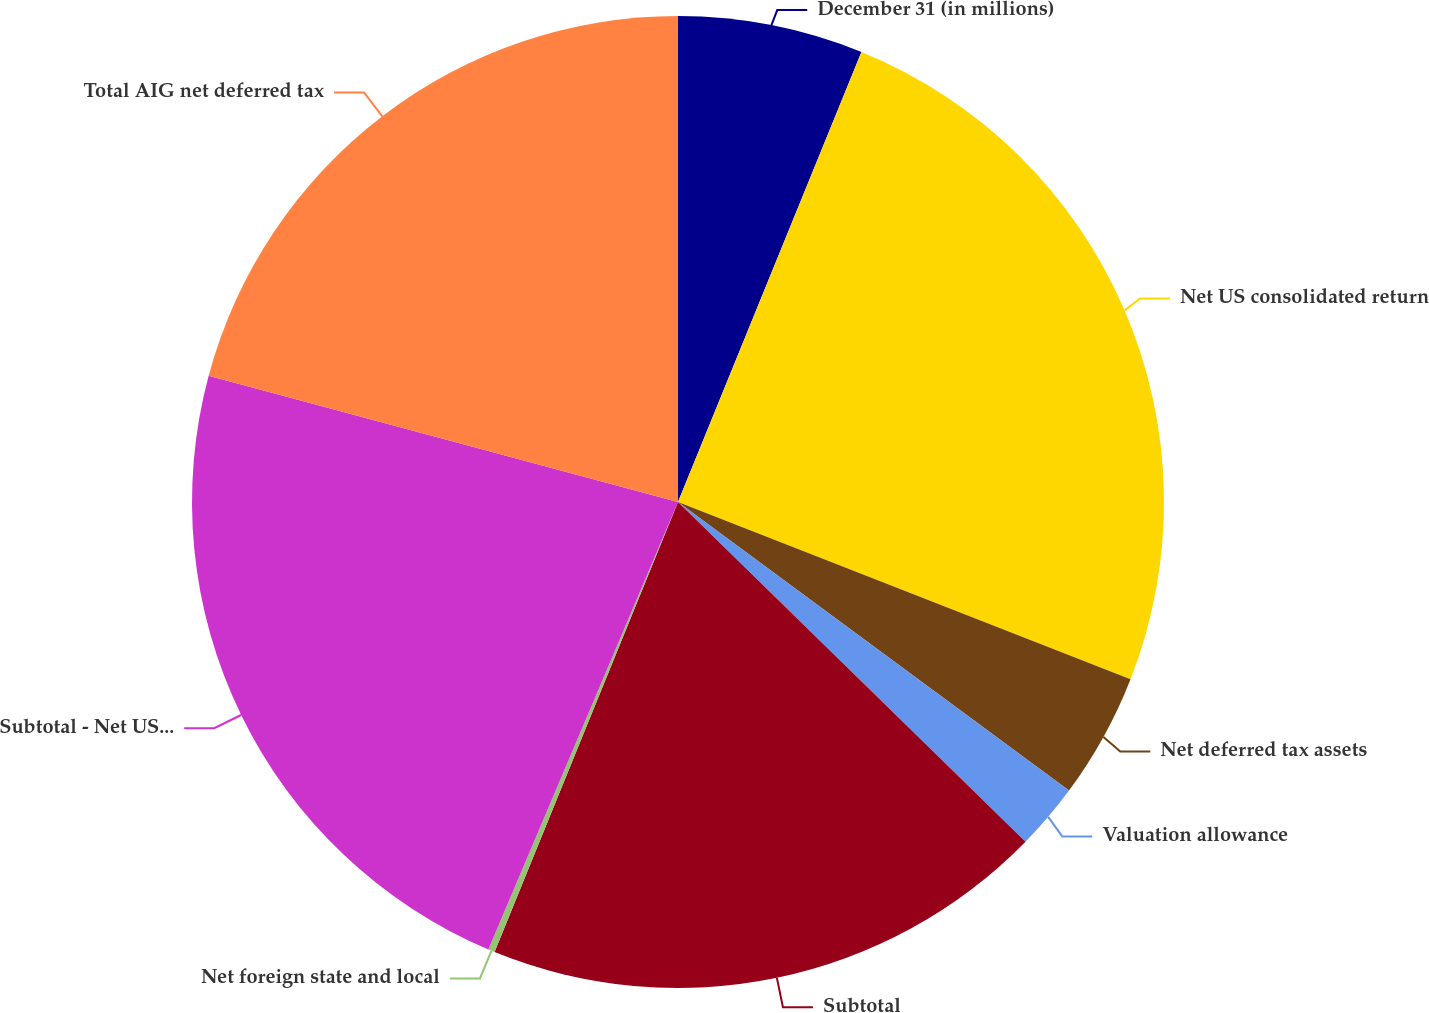<chart> <loc_0><loc_0><loc_500><loc_500><pie_chart><fcel>December 31 (in millions)<fcel>Net US consolidated return<fcel>Net deferred tax assets<fcel>Valuation allowance<fcel>Subtotal<fcel>Net foreign state and local<fcel>Subtotal - Net US foreign<fcel>Total AIG net deferred tax<nl><fcel>6.16%<fcel>24.78%<fcel>4.18%<fcel>2.2%<fcel>18.84%<fcel>0.22%<fcel>22.8%<fcel>20.82%<nl></chart> 